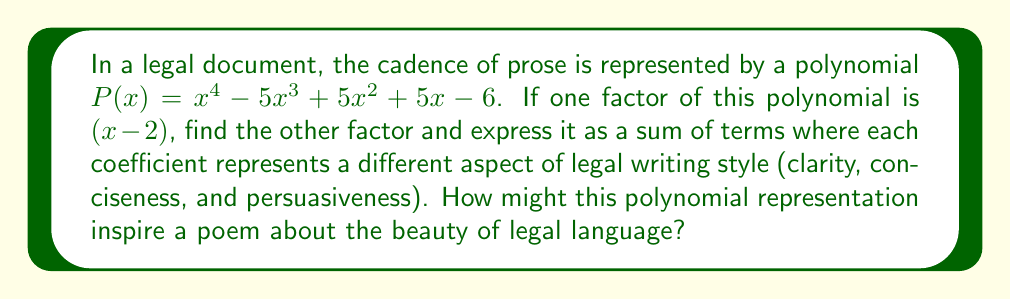Can you answer this question? 1) Given that $(x - 2)$ is a factor, we can divide $P(x)$ by $(x - 2)$ to find the other factor.

2) Using polynomial long division:

$$
\begin{array}{r}
x^3 - 3x^2 - x + 3 \\
x - 2 \enclose{longdiv}{x^4 - 5x^3 + 5x^2 + 5x - 6} \\
\underline{x^4 - 2x^3} \\
-3x^3 + 5x^2 \\
\underline{-3x^3 + 6x^2} \\
-x^2 + 5x \\
\underline{-x^2 + 2x} \\
3x - 6 \\
\underline{3x - 6} \\
0
\end{array}
$$

3) The result of the division is $x^3 - 3x^2 - x + 3$

4) Therefore, $P(x) = (x - 2)(x^3 - 3x^2 - x + 3)$

5) We can interpret the coefficients of the cubic factor as follows:
   - 1: Base rhythm of legal prose
   - -3: Clarity of expression
   - -1: Conciseness of language
   - 3: Persuasiveness of argument

6) The polynomial representation $x^3 - 3x^2 - x + 3$ could inspire a poem about legal language by considering:
   - The cubic nature suggesting complexity
   - The negative coefficients representing challenges in clarity and conciseness
   - The positive final term emphasizing the ultimate goal of persuasiveness

This mathematical representation of legal prose rhythm could spark poetic reflections on the interplay between complexity and clarity in legal writing.
Answer: $(x - 2)(x^3 - 3x^2 - x + 3)$ 